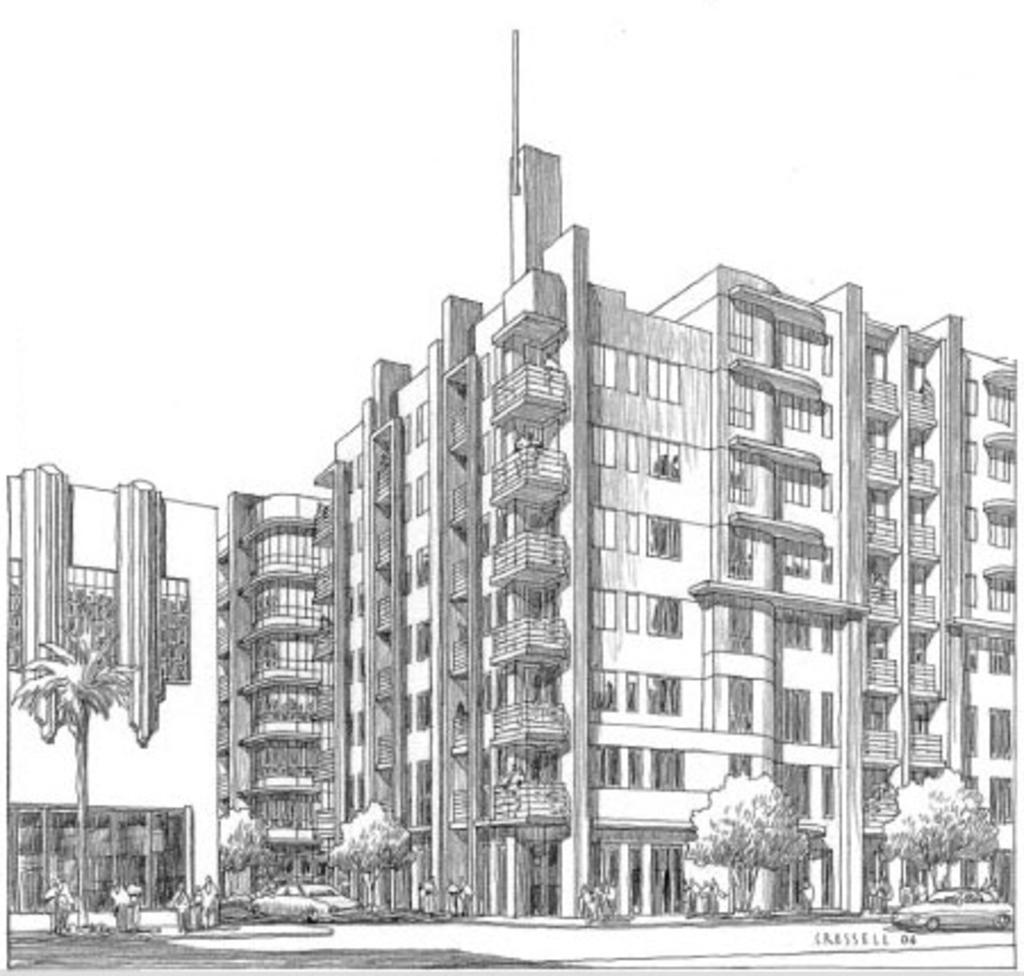What is depicted in the image? There is a painting in the image. What can be seen in the painting? The painting contains a building with windows and trees. Are there any vehicles in the painting? Yes, there are cars in the painting. What type of pan can be seen hanging from the building in the painting? There is no pan visible in the painting; it only features a building with windows, trees, and cars. 